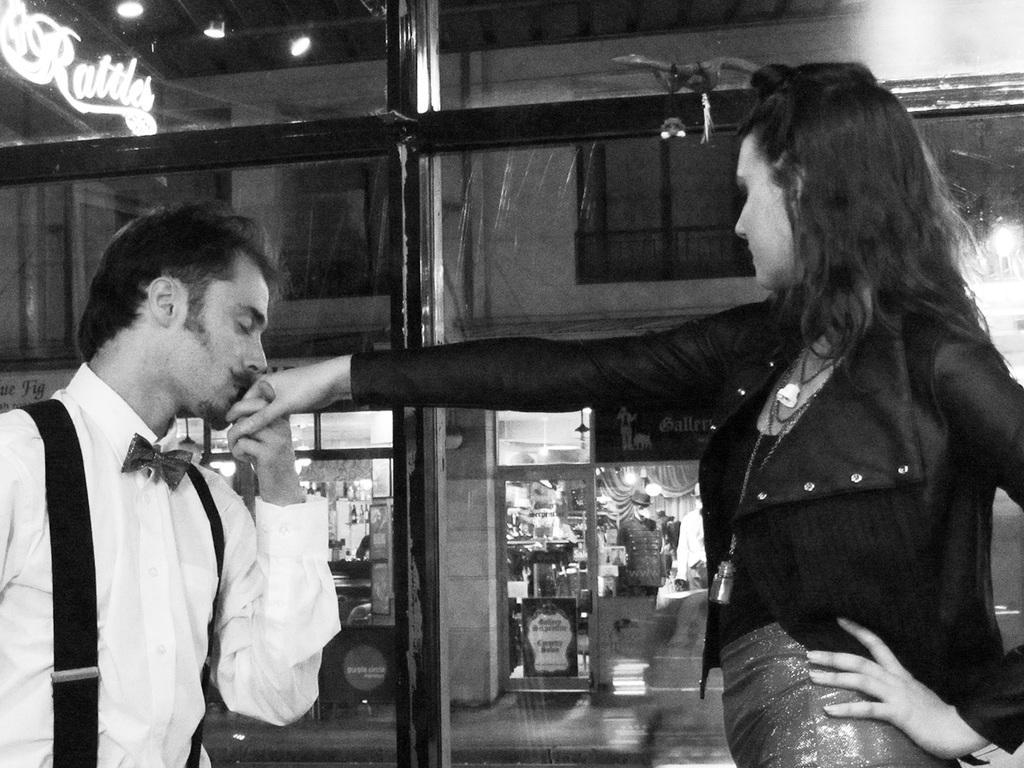Describe this image in one or two sentences. This is a black and white picture, in this image we can see two persons, among them, one person is kissing the other person's hand, in the background, we can see a building, there are some windows, lights and boards with some text, inside the building we can see some objects. 